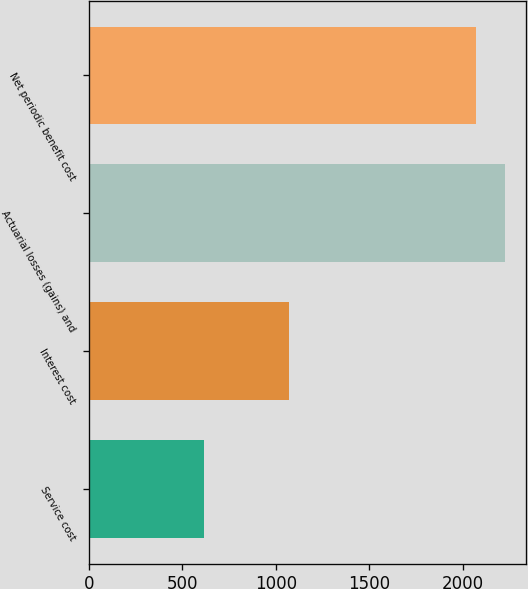Convert chart. <chart><loc_0><loc_0><loc_500><loc_500><bar_chart><fcel>Service cost<fcel>Interest cost<fcel>Actuarial losses (gains) and<fcel>Net periodic benefit cost<nl><fcel>615<fcel>1068<fcel>2223.9<fcel>2070<nl></chart> 